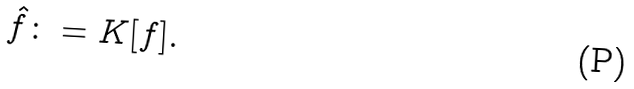<formula> <loc_0><loc_0><loc_500><loc_500>\hat { f } \colon = K [ f ] .</formula> 